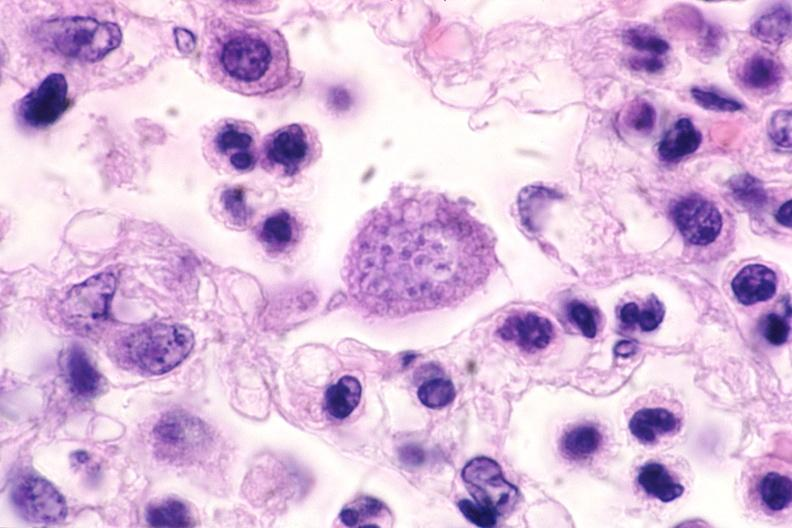s nervous present?
Answer the question using a single word or phrase. Yes 